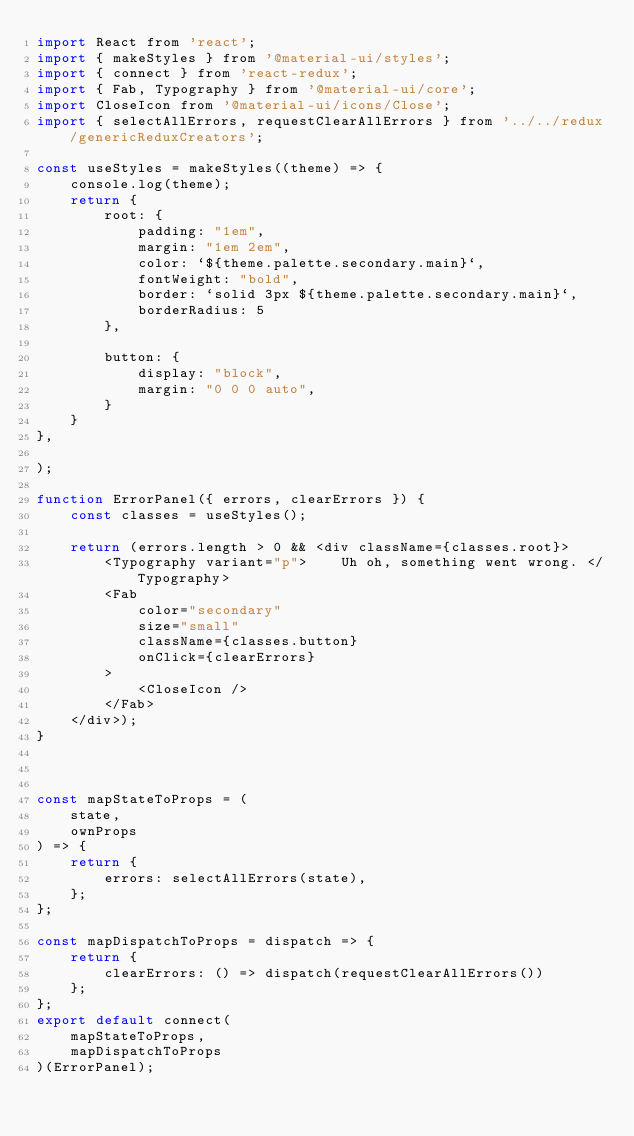<code> <loc_0><loc_0><loc_500><loc_500><_JavaScript_>import React from 'react';
import { makeStyles } from '@material-ui/styles';
import { connect } from 'react-redux';
import { Fab, Typography } from '@material-ui/core';
import CloseIcon from '@material-ui/icons/Close';
import { selectAllErrors, requestClearAllErrors } from '../../redux/genericReduxCreators';

const useStyles = makeStyles((theme) => {
    console.log(theme);
    return {
        root: {
            padding: "1em",
            margin: "1em 2em",
            color: `${theme.palette.secondary.main}`,
            fontWeight: "bold",
            border: `solid 3px ${theme.palette.secondary.main}`,
            borderRadius: 5
        },

        button: {
            display: "block",
            margin: "0 0 0 auto",
        }
    }
},

);

function ErrorPanel({ errors, clearErrors }) {
    const classes = useStyles();

    return (errors.length > 0 && <div className={classes.root}>
        <Typography variant="p">    Uh oh, something went wrong. </Typography>
        <Fab
            color="secondary"
            size="small"
            className={classes.button}
            onClick={clearErrors}
        >
            <CloseIcon />
        </Fab>
    </div>);
}



const mapStateToProps = (
    state,
    ownProps
) => {
    return {
        errors: selectAllErrors(state),
    };
};

const mapDispatchToProps = dispatch => {
    return {
        clearErrors: () => dispatch(requestClearAllErrors())
    };
};
export default connect(
    mapStateToProps,
    mapDispatchToProps
)(ErrorPanel);</code> 